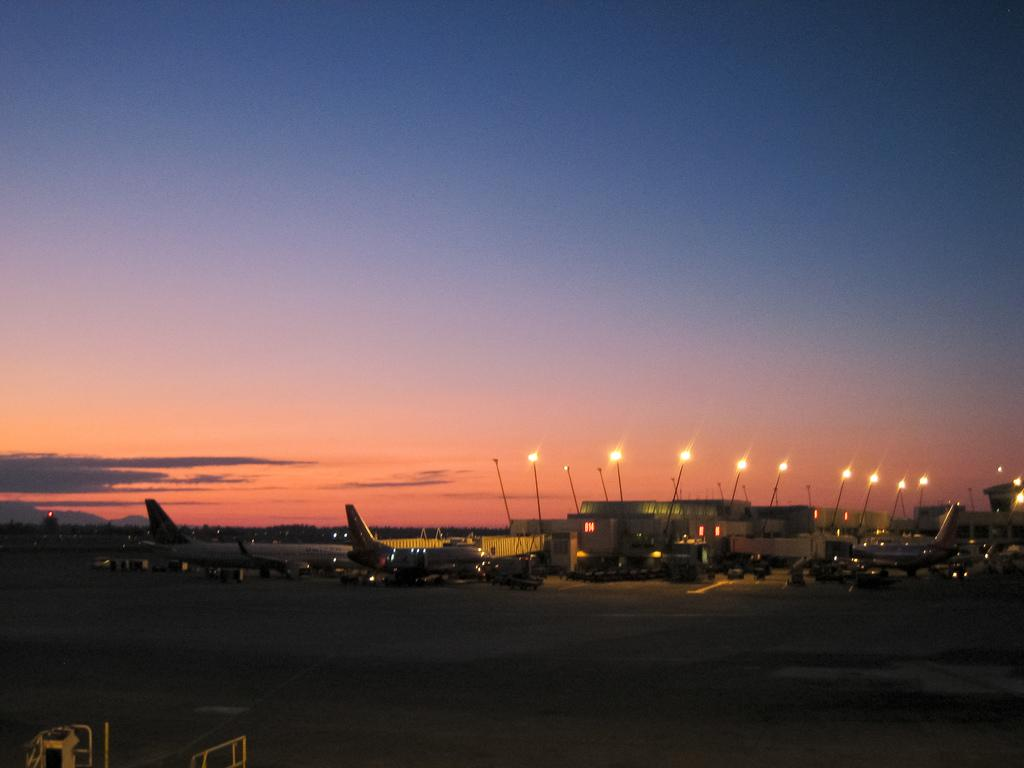What type of transportation is visible on the ground in the image? There are airplanes and vehicles on the ground in the image. What can be seen in the background of the image? There are buildings and lights in the background of the image. What is the condition of the sky in the image? The sky is cloudy in the image. Can you see a request for a seafood dish being made in the image? There is no request for a seafood dish present in the image. What type of oven is visible in the image? There is no oven present in the image. 